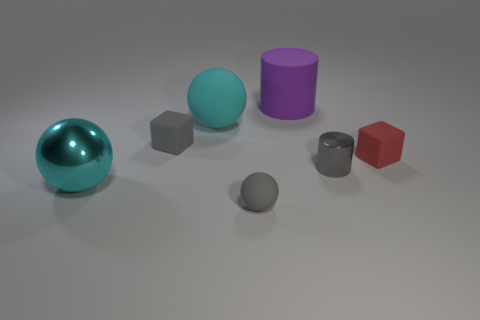Subtract all cyan balls. Subtract all purple blocks. How many balls are left? 1 Add 1 rubber cylinders. How many objects exist? 8 Subtract all spheres. How many objects are left? 4 Add 4 tiny red matte objects. How many tiny red matte objects exist? 5 Subtract 0 blue cubes. How many objects are left? 7 Subtract all big yellow metal objects. Subtract all tiny gray cylinders. How many objects are left? 6 Add 5 matte blocks. How many matte blocks are left? 7 